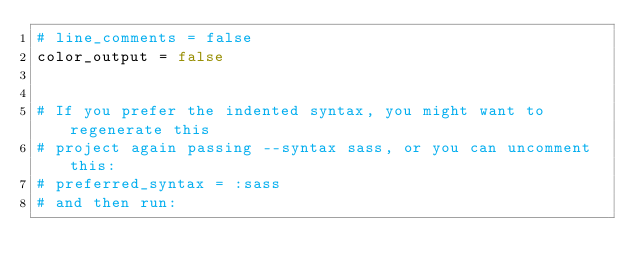<code> <loc_0><loc_0><loc_500><loc_500><_Ruby_># line_comments = false
color_output = false


# If you prefer the indented syntax, you might want to regenerate this
# project again passing --syntax sass, or you can uncomment this:
# preferred_syntax = :sass
# and then run:</code> 